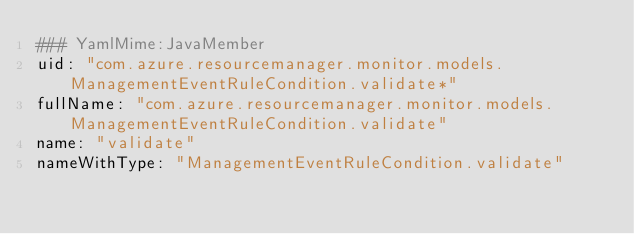<code> <loc_0><loc_0><loc_500><loc_500><_YAML_>### YamlMime:JavaMember
uid: "com.azure.resourcemanager.monitor.models.ManagementEventRuleCondition.validate*"
fullName: "com.azure.resourcemanager.monitor.models.ManagementEventRuleCondition.validate"
name: "validate"
nameWithType: "ManagementEventRuleCondition.validate"</code> 